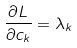<formula> <loc_0><loc_0><loc_500><loc_500>\frac { \partial L } { \partial c _ { k } } = \lambda _ { k }</formula> 